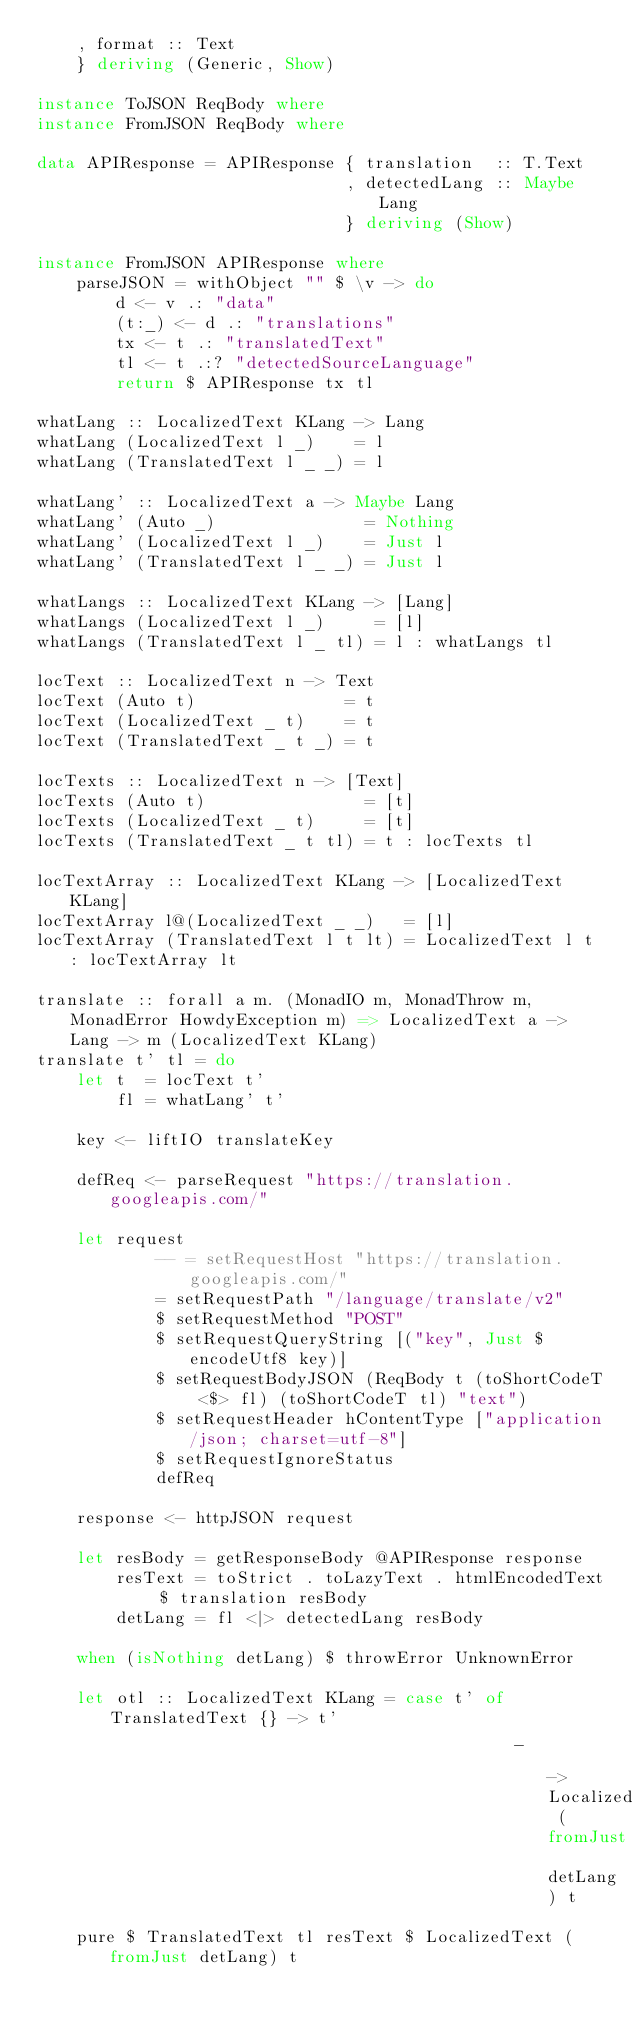<code> <loc_0><loc_0><loc_500><loc_500><_Haskell_>    , format :: Text
    } deriving (Generic, Show)

instance ToJSON ReqBody where
instance FromJSON ReqBody where

data APIResponse = APIResponse { translation  :: T.Text
                               , detectedLang :: Maybe Lang
                               } deriving (Show)

instance FromJSON APIResponse where
    parseJSON = withObject "" $ \v -> do
        d <- v .: "data"
        (t:_) <- d .: "translations"
        tx <- t .: "translatedText"
        tl <- t .:? "detectedSourceLanguage"
        return $ APIResponse tx tl

whatLang :: LocalizedText KLang -> Lang
whatLang (LocalizedText l _)    = l
whatLang (TranslatedText l _ _) = l

whatLang' :: LocalizedText a -> Maybe Lang
whatLang' (Auto _)               = Nothing
whatLang' (LocalizedText l _)    = Just l
whatLang' (TranslatedText l _ _) = Just l

whatLangs :: LocalizedText KLang -> [Lang]
whatLangs (LocalizedText l _)     = [l]
whatLangs (TranslatedText l _ tl) = l : whatLangs tl

locText :: LocalizedText n -> Text
locText (Auto t)               = t
locText (LocalizedText _ t)    = t
locText (TranslatedText _ t _) = t

locTexts :: LocalizedText n -> [Text]
locTexts (Auto t)                = [t]
locTexts (LocalizedText _ t)     = [t]
locTexts (TranslatedText _ t tl) = t : locTexts tl

locTextArray :: LocalizedText KLang -> [LocalizedText KLang]
locTextArray l@(LocalizedText _ _)   = [l]
locTextArray (TranslatedText l t lt) = LocalizedText l t : locTextArray lt

translate :: forall a m. (MonadIO m, MonadThrow m, MonadError HowdyException m) => LocalizedText a -> Lang -> m (LocalizedText KLang)
translate t' tl = do
    let t  = locText t'
        fl = whatLang' t'

    key <- liftIO translateKey

    defReq <- parseRequest "https://translation.googleapis.com/"

    let request
            -- = setRequestHost "https://translation.googleapis.com/"
            = setRequestPath "/language/translate/v2"
            $ setRequestMethod "POST"
            $ setRequestQueryString [("key", Just $ encodeUtf8 key)]
            $ setRequestBodyJSON (ReqBody t (toShortCodeT <$> fl) (toShortCodeT tl) "text")
            $ setRequestHeader hContentType ["application/json; charset=utf-8"]
            $ setRequestIgnoreStatus
            defReq

    response <- httpJSON request

    let resBody = getResponseBody @APIResponse response
        resText = toStrict . toLazyText . htmlEncodedText $ translation resBody
        detLang = fl <|> detectedLang resBody

    when (isNothing detLang) $ throwError UnknownError

    let otl :: LocalizedText KLang = case t' of TranslatedText {} -> t'
                                                _                 -> LocalizedText (fromJust detLang) t

    pure $ TranslatedText tl resText $ LocalizedText (fromJust detLang) t
</code> 